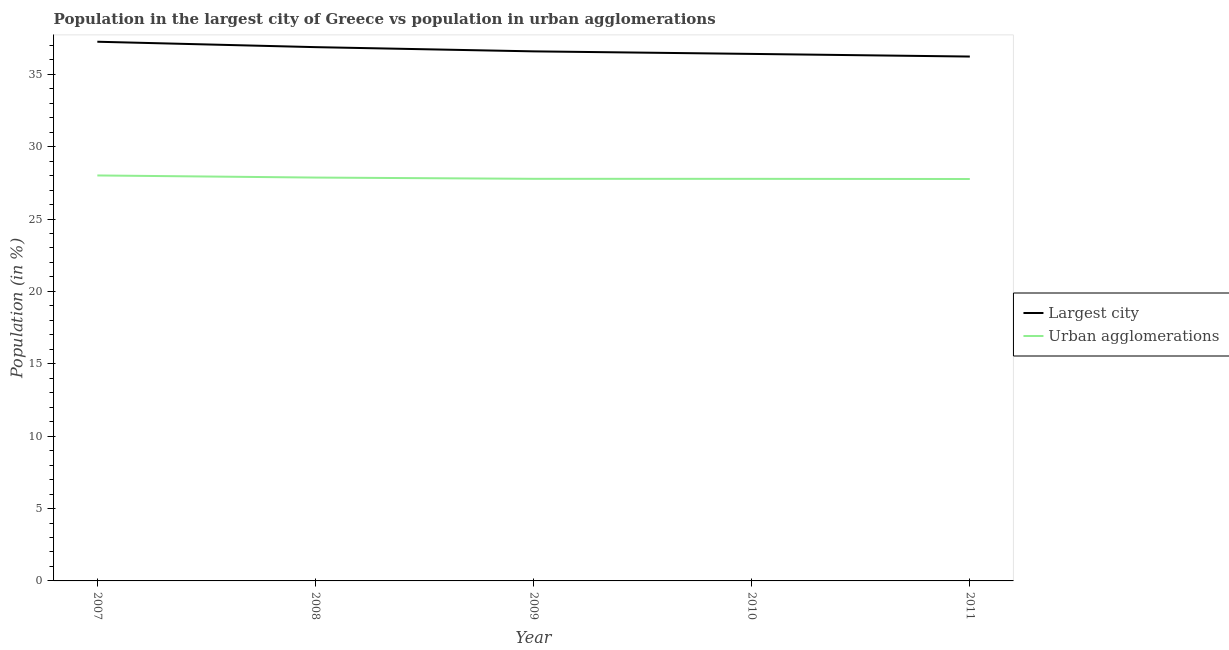What is the population in the largest city in 2010?
Give a very brief answer. 36.41. Across all years, what is the maximum population in urban agglomerations?
Keep it short and to the point. 28.01. Across all years, what is the minimum population in the largest city?
Provide a succinct answer. 36.22. In which year was the population in the largest city maximum?
Make the answer very short. 2007. What is the total population in urban agglomerations in the graph?
Your answer should be very brief. 139.19. What is the difference between the population in urban agglomerations in 2009 and that in 2010?
Give a very brief answer. 0. What is the difference between the population in urban agglomerations in 2010 and the population in the largest city in 2008?
Ensure brevity in your answer.  -9.1. What is the average population in urban agglomerations per year?
Offer a very short reply. 27.84. In the year 2011, what is the difference between the population in the largest city and population in urban agglomerations?
Ensure brevity in your answer.  8.46. What is the ratio of the population in urban agglomerations in 2007 to that in 2010?
Make the answer very short. 1.01. Is the population in urban agglomerations in 2007 less than that in 2009?
Your answer should be very brief. No. What is the difference between the highest and the second highest population in urban agglomerations?
Make the answer very short. 0.14. What is the difference between the highest and the lowest population in urban agglomerations?
Keep it short and to the point. 0.24. Does the population in the largest city monotonically increase over the years?
Provide a short and direct response. No. Is the population in the largest city strictly greater than the population in urban agglomerations over the years?
Your response must be concise. Yes. Is the population in urban agglomerations strictly less than the population in the largest city over the years?
Offer a terse response. Yes. How many lines are there?
Make the answer very short. 2. What is the difference between two consecutive major ticks on the Y-axis?
Provide a short and direct response. 5. Are the values on the major ticks of Y-axis written in scientific E-notation?
Provide a succinct answer. No. Does the graph contain grids?
Offer a terse response. No. Where does the legend appear in the graph?
Provide a succinct answer. Center right. How many legend labels are there?
Your response must be concise. 2. How are the legend labels stacked?
Make the answer very short. Vertical. What is the title of the graph?
Your answer should be very brief. Population in the largest city of Greece vs population in urban agglomerations. What is the label or title of the X-axis?
Offer a very short reply. Year. What is the label or title of the Y-axis?
Your answer should be very brief. Population (in %). What is the Population (in %) in Largest city in 2007?
Provide a short and direct response. 37.25. What is the Population (in %) in Urban agglomerations in 2007?
Your response must be concise. 28.01. What is the Population (in %) in Largest city in 2008?
Give a very brief answer. 36.87. What is the Population (in %) of Urban agglomerations in 2008?
Ensure brevity in your answer.  27.86. What is the Population (in %) in Largest city in 2009?
Provide a succinct answer. 36.58. What is the Population (in %) in Urban agglomerations in 2009?
Your answer should be compact. 27.78. What is the Population (in %) in Largest city in 2010?
Keep it short and to the point. 36.41. What is the Population (in %) of Urban agglomerations in 2010?
Offer a very short reply. 27.77. What is the Population (in %) in Largest city in 2011?
Keep it short and to the point. 36.22. What is the Population (in %) in Urban agglomerations in 2011?
Your response must be concise. 27.76. Across all years, what is the maximum Population (in %) of Largest city?
Give a very brief answer. 37.25. Across all years, what is the maximum Population (in %) of Urban agglomerations?
Give a very brief answer. 28.01. Across all years, what is the minimum Population (in %) in Largest city?
Your answer should be compact. 36.22. Across all years, what is the minimum Population (in %) of Urban agglomerations?
Provide a short and direct response. 27.76. What is the total Population (in %) of Largest city in the graph?
Offer a very short reply. 183.33. What is the total Population (in %) of Urban agglomerations in the graph?
Give a very brief answer. 139.19. What is the difference between the Population (in %) in Largest city in 2007 and that in 2008?
Provide a succinct answer. 0.37. What is the difference between the Population (in %) of Urban agglomerations in 2007 and that in 2008?
Provide a short and direct response. 0.14. What is the difference between the Population (in %) in Largest city in 2007 and that in 2009?
Give a very brief answer. 0.67. What is the difference between the Population (in %) in Urban agglomerations in 2007 and that in 2009?
Your response must be concise. 0.23. What is the difference between the Population (in %) of Largest city in 2007 and that in 2010?
Your answer should be compact. 0.84. What is the difference between the Population (in %) of Urban agglomerations in 2007 and that in 2010?
Make the answer very short. 0.23. What is the difference between the Population (in %) of Largest city in 2007 and that in 2011?
Make the answer very short. 1.02. What is the difference between the Population (in %) in Urban agglomerations in 2007 and that in 2011?
Offer a very short reply. 0.24. What is the difference between the Population (in %) of Largest city in 2008 and that in 2009?
Provide a short and direct response. 0.29. What is the difference between the Population (in %) of Urban agglomerations in 2008 and that in 2009?
Provide a short and direct response. 0.09. What is the difference between the Population (in %) of Largest city in 2008 and that in 2010?
Provide a succinct answer. 0.47. What is the difference between the Population (in %) in Urban agglomerations in 2008 and that in 2010?
Your response must be concise. 0.09. What is the difference between the Population (in %) in Largest city in 2008 and that in 2011?
Give a very brief answer. 0.65. What is the difference between the Population (in %) in Urban agglomerations in 2008 and that in 2011?
Ensure brevity in your answer.  0.1. What is the difference between the Population (in %) of Largest city in 2009 and that in 2010?
Provide a short and direct response. 0.18. What is the difference between the Population (in %) in Urban agglomerations in 2009 and that in 2010?
Keep it short and to the point. 0. What is the difference between the Population (in %) in Largest city in 2009 and that in 2011?
Make the answer very short. 0.36. What is the difference between the Population (in %) in Urban agglomerations in 2009 and that in 2011?
Give a very brief answer. 0.01. What is the difference between the Population (in %) of Largest city in 2010 and that in 2011?
Your answer should be compact. 0.18. What is the difference between the Population (in %) in Urban agglomerations in 2010 and that in 2011?
Your answer should be very brief. 0.01. What is the difference between the Population (in %) of Largest city in 2007 and the Population (in %) of Urban agglomerations in 2008?
Make the answer very short. 9.38. What is the difference between the Population (in %) of Largest city in 2007 and the Population (in %) of Urban agglomerations in 2009?
Your answer should be very brief. 9.47. What is the difference between the Population (in %) of Largest city in 2007 and the Population (in %) of Urban agglomerations in 2010?
Make the answer very short. 9.47. What is the difference between the Population (in %) in Largest city in 2007 and the Population (in %) in Urban agglomerations in 2011?
Offer a terse response. 9.48. What is the difference between the Population (in %) of Largest city in 2008 and the Population (in %) of Urban agglomerations in 2009?
Offer a very short reply. 9.1. What is the difference between the Population (in %) in Largest city in 2008 and the Population (in %) in Urban agglomerations in 2010?
Make the answer very short. 9.1. What is the difference between the Population (in %) of Largest city in 2008 and the Population (in %) of Urban agglomerations in 2011?
Keep it short and to the point. 9.11. What is the difference between the Population (in %) in Largest city in 2009 and the Population (in %) in Urban agglomerations in 2010?
Offer a very short reply. 8.81. What is the difference between the Population (in %) of Largest city in 2009 and the Population (in %) of Urban agglomerations in 2011?
Give a very brief answer. 8.82. What is the difference between the Population (in %) in Largest city in 2010 and the Population (in %) in Urban agglomerations in 2011?
Offer a very short reply. 8.64. What is the average Population (in %) of Largest city per year?
Keep it short and to the point. 36.67. What is the average Population (in %) of Urban agglomerations per year?
Give a very brief answer. 27.84. In the year 2007, what is the difference between the Population (in %) in Largest city and Population (in %) in Urban agglomerations?
Provide a short and direct response. 9.24. In the year 2008, what is the difference between the Population (in %) of Largest city and Population (in %) of Urban agglomerations?
Provide a succinct answer. 9.01. In the year 2009, what is the difference between the Population (in %) in Largest city and Population (in %) in Urban agglomerations?
Make the answer very short. 8.8. In the year 2010, what is the difference between the Population (in %) of Largest city and Population (in %) of Urban agglomerations?
Provide a succinct answer. 8.63. In the year 2011, what is the difference between the Population (in %) of Largest city and Population (in %) of Urban agglomerations?
Provide a short and direct response. 8.46. What is the ratio of the Population (in %) in Urban agglomerations in 2007 to that in 2008?
Ensure brevity in your answer.  1.01. What is the ratio of the Population (in %) of Largest city in 2007 to that in 2009?
Offer a very short reply. 1.02. What is the ratio of the Population (in %) of Urban agglomerations in 2007 to that in 2009?
Ensure brevity in your answer.  1.01. What is the ratio of the Population (in %) of Largest city in 2007 to that in 2010?
Keep it short and to the point. 1.02. What is the ratio of the Population (in %) in Urban agglomerations in 2007 to that in 2010?
Provide a short and direct response. 1.01. What is the ratio of the Population (in %) of Largest city in 2007 to that in 2011?
Ensure brevity in your answer.  1.03. What is the ratio of the Population (in %) of Urban agglomerations in 2007 to that in 2011?
Ensure brevity in your answer.  1.01. What is the ratio of the Population (in %) of Largest city in 2008 to that in 2009?
Offer a terse response. 1.01. What is the ratio of the Population (in %) of Largest city in 2008 to that in 2010?
Provide a short and direct response. 1.01. What is the ratio of the Population (in %) of Largest city in 2008 to that in 2011?
Offer a very short reply. 1.02. What is the ratio of the Population (in %) in Largest city in 2009 to that in 2010?
Provide a short and direct response. 1. What is the ratio of the Population (in %) of Largest city in 2009 to that in 2011?
Your answer should be compact. 1.01. What is the ratio of the Population (in %) of Urban agglomerations in 2009 to that in 2011?
Provide a succinct answer. 1. What is the ratio of the Population (in %) of Largest city in 2010 to that in 2011?
Ensure brevity in your answer.  1. What is the ratio of the Population (in %) in Urban agglomerations in 2010 to that in 2011?
Give a very brief answer. 1. What is the difference between the highest and the second highest Population (in %) of Largest city?
Your response must be concise. 0.37. What is the difference between the highest and the second highest Population (in %) of Urban agglomerations?
Offer a terse response. 0.14. What is the difference between the highest and the lowest Population (in %) in Largest city?
Offer a very short reply. 1.02. What is the difference between the highest and the lowest Population (in %) of Urban agglomerations?
Ensure brevity in your answer.  0.24. 